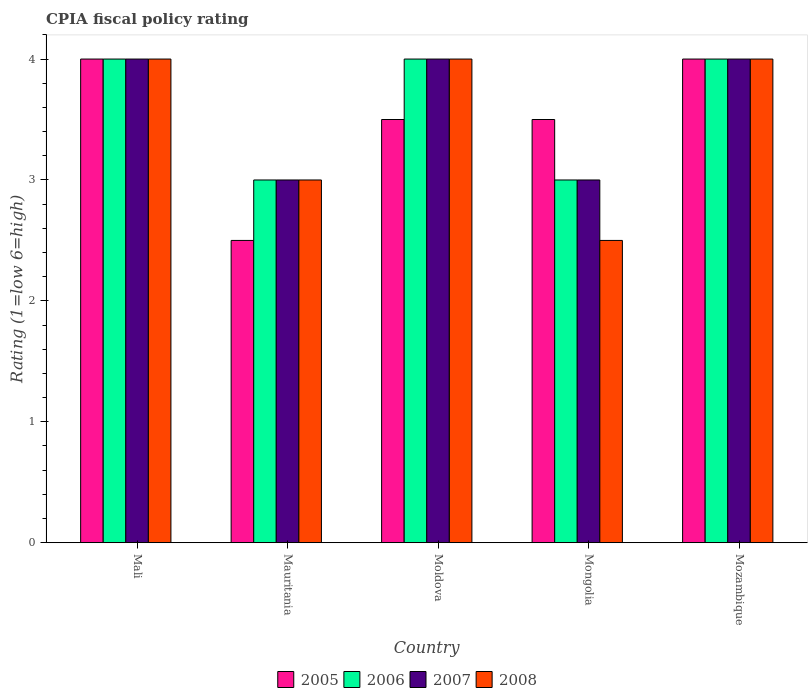Are the number of bars per tick equal to the number of legend labels?
Offer a terse response. Yes. How many bars are there on the 3rd tick from the left?
Give a very brief answer. 4. How many bars are there on the 3rd tick from the right?
Provide a short and direct response. 4. What is the label of the 5th group of bars from the left?
Offer a terse response. Mozambique. In how many cases, is the number of bars for a given country not equal to the number of legend labels?
Your answer should be compact. 0. Across all countries, what is the minimum CPIA rating in 2008?
Offer a terse response. 2.5. In which country was the CPIA rating in 2006 maximum?
Your answer should be very brief. Mali. In which country was the CPIA rating in 2007 minimum?
Provide a short and direct response. Mauritania. What is the average CPIA rating in 2005 per country?
Your answer should be very brief. 3.5. What is the difference between the CPIA rating of/in 2006 and CPIA rating of/in 2008 in Mongolia?
Offer a very short reply. 0.5. In how many countries, is the CPIA rating in 2008 greater than 2.2?
Your answer should be very brief. 5. What is the ratio of the CPIA rating in 2007 in Mauritania to that in Mozambique?
Provide a short and direct response. 0.75. What is the difference between the highest and the second highest CPIA rating in 2005?
Give a very brief answer. -0.5. Is the sum of the CPIA rating in 2008 in Mauritania and Mozambique greater than the maximum CPIA rating in 2006 across all countries?
Ensure brevity in your answer.  Yes. What does the 1st bar from the left in Mauritania represents?
Your answer should be very brief. 2005. Is it the case that in every country, the sum of the CPIA rating in 2008 and CPIA rating in 2005 is greater than the CPIA rating in 2007?
Provide a short and direct response. Yes. Are all the bars in the graph horizontal?
Provide a short and direct response. No. Where does the legend appear in the graph?
Your answer should be very brief. Bottom center. What is the title of the graph?
Ensure brevity in your answer.  CPIA fiscal policy rating. Does "1985" appear as one of the legend labels in the graph?
Make the answer very short. No. What is the label or title of the Y-axis?
Offer a terse response. Rating (1=low 6=high). What is the Rating (1=low 6=high) in 2005 in Mali?
Provide a short and direct response. 4. What is the Rating (1=low 6=high) of 2007 in Mauritania?
Your answer should be compact. 3. What is the Rating (1=low 6=high) of 2006 in Moldova?
Provide a short and direct response. 4. What is the Rating (1=low 6=high) in 2007 in Moldova?
Provide a succinct answer. 4. What is the Rating (1=low 6=high) in 2008 in Moldova?
Give a very brief answer. 4. What is the Rating (1=low 6=high) in 2005 in Mozambique?
Offer a very short reply. 4. What is the Rating (1=low 6=high) in 2008 in Mozambique?
Offer a very short reply. 4. Across all countries, what is the maximum Rating (1=low 6=high) in 2005?
Your answer should be compact. 4. Across all countries, what is the maximum Rating (1=low 6=high) of 2006?
Provide a succinct answer. 4. Across all countries, what is the maximum Rating (1=low 6=high) in 2007?
Keep it short and to the point. 4. Across all countries, what is the maximum Rating (1=low 6=high) in 2008?
Your answer should be compact. 4. Across all countries, what is the minimum Rating (1=low 6=high) of 2006?
Offer a very short reply. 3. Across all countries, what is the minimum Rating (1=low 6=high) of 2007?
Provide a succinct answer. 3. Across all countries, what is the minimum Rating (1=low 6=high) of 2008?
Keep it short and to the point. 2.5. What is the total Rating (1=low 6=high) in 2007 in the graph?
Offer a terse response. 18. What is the difference between the Rating (1=low 6=high) in 2005 in Mali and that in Mauritania?
Keep it short and to the point. 1.5. What is the difference between the Rating (1=low 6=high) in 2006 in Mali and that in Mauritania?
Provide a short and direct response. 1. What is the difference between the Rating (1=low 6=high) of 2008 in Mali and that in Mauritania?
Give a very brief answer. 1. What is the difference between the Rating (1=low 6=high) in 2005 in Mali and that in Moldova?
Your answer should be compact. 0.5. What is the difference between the Rating (1=low 6=high) in 2006 in Mali and that in Mongolia?
Your answer should be very brief. 1. What is the difference between the Rating (1=low 6=high) of 2007 in Mali and that in Mongolia?
Give a very brief answer. 1. What is the difference between the Rating (1=low 6=high) of 2008 in Mali and that in Mongolia?
Keep it short and to the point. 1.5. What is the difference between the Rating (1=low 6=high) in 2005 in Mali and that in Mozambique?
Ensure brevity in your answer.  0. What is the difference between the Rating (1=low 6=high) in 2006 in Mali and that in Mozambique?
Give a very brief answer. 0. What is the difference between the Rating (1=low 6=high) in 2007 in Mali and that in Mozambique?
Offer a terse response. 0. What is the difference between the Rating (1=low 6=high) of 2008 in Mali and that in Mozambique?
Your answer should be very brief. 0. What is the difference between the Rating (1=low 6=high) of 2005 in Mauritania and that in Moldova?
Ensure brevity in your answer.  -1. What is the difference between the Rating (1=low 6=high) of 2007 in Mauritania and that in Moldova?
Your answer should be compact. -1. What is the difference between the Rating (1=low 6=high) of 2008 in Mauritania and that in Moldova?
Offer a very short reply. -1. What is the difference between the Rating (1=low 6=high) in 2005 in Mauritania and that in Mongolia?
Provide a short and direct response. -1. What is the difference between the Rating (1=low 6=high) in 2006 in Mauritania and that in Mozambique?
Your answer should be compact. -1. What is the difference between the Rating (1=low 6=high) in 2008 in Mauritania and that in Mozambique?
Provide a succinct answer. -1. What is the difference between the Rating (1=low 6=high) of 2005 in Moldova and that in Mongolia?
Keep it short and to the point. 0. What is the difference between the Rating (1=low 6=high) in 2006 in Moldova and that in Mongolia?
Make the answer very short. 1. What is the difference between the Rating (1=low 6=high) of 2007 in Moldova and that in Mongolia?
Your answer should be compact. 1. What is the difference between the Rating (1=low 6=high) in 2008 in Moldova and that in Mongolia?
Make the answer very short. 1.5. What is the difference between the Rating (1=low 6=high) in 2005 in Moldova and that in Mozambique?
Offer a terse response. -0.5. What is the difference between the Rating (1=low 6=high) of 2006 in Moldova and that in Mozambique?
Make the answer very short. 0. What is the difference between the Rating (1=low 6=high) in 2008 in Moldova and that in Mozambique?
Offer a very short reply. 0. What is the difference between the Rating (1=low 6=high) in 2005 in Mongolia and that in Mozambique?
Make the answer very short. -0.5. What is the difference between the Rating (1=low 6=high) of 2006 in Mongolia and that in Mozambique?
Keep it short and to the point. -1. What is the difference between the Rating (1=low 6=high) in 2005 in Mali and the Rating (1=low 6=high) in 2007 in Mauritania?
Offer a terse response. 1. What is the difference between the Rating (1=low 6=high) in 2006 in Mali and the Rating (1=low 6=high) in 2007 in Mauritania?
Give a very brief answer. 1. What is the difference between the Rating (1=low 6=high) in 2005 in Mali and the Rating (1=low 6=high) in 2006 in Moldova?
Offer a very short reply. 0. What is the difference between the Rating (1=low 6=high) in 2005 in Mali and the Rating (1=low 6=high) in 2007 in Moldova?
Offer a terse response. 0. What is the difference between the Rating (1=low 6=high) of 2006 in Mali and the Rating (1=low 6=high) of 2008 in Moldova?
Provide a short and direct response. 0. What is the difference between the Rating (1=low 6=high) of 2007 in Mali and the Rating (1=low 6=high) of 2008 in Moldova?
Give a very brief answer. 0. What is the difference between the Rating (1=low 6=high) in 2005 in Mali and the Rating (1=low 6=high) in 2007 in Mongolia?
Provide a succinct answer. 1. What is the difference between the Rating (1=low 6=high) in 2007 in Mali and the Rating (1=low 6=high) in 2008 in Mongolia?
Make the answer very short. 1.5. What is the difference between the Rating (1=low 6=high) of 2005 in Mali and the Rating (1=low 6=high) of 2006 in Mozambique?
Provide a succinct answer. 0. What is the difference between the Rating (1=low 6=high) of 2005 in Mali and the Rating (1=low 6=high) of 2007 in Mozambique?
Your answer should be compact. 0. What is the difference between the Rating (1=low 6=high) of 2005 in Mali and the Rating (1=low 6=high) of 2008 in Mozambique?
Give a very brief answer. 0. What is the difference between the Rating (1=low 6=high) in 2007 in Mali and the Rating (1=low 6=high) in 2008 in Mozambique?
Provide a short and direct response. 0. What is the difference between the Rating (1=low 6=high) of 2005 in Mauritania and the Rating (1=low 6=high) of 2006 in Moldova?
Provide a succinct answer. -1.5. What is the difference between the Rating (1=low 6=high) of 2005 in Mauritania and the Rating (1=low 6=high) of 2007 in Moldova?
Provide a short and direct response. -1.5. What is the difference between the Rating (1=low 6=high) of 2006 in Mauritania and the Rating (1=low 6=high) of 2007 in Moldova?
Your response must be concise. -1. What is the difference between the Rating (1=low 6=high) in 2006 in Mauritania and the Rating (1=low 6=high) in 2008 in Moldova?
Keep it short and to the point. -1. What is the difference between the Rating (1=low 6=high) in 2005 in Mauritania and the Rating (1=low 6=high) in 2006 in Mongolia?
Your response must be concise. -0.5. What is the difference between the Rating (1=low 6=high) in 2006 in Mauritania and the Rating (1=low 6=high) in 2007 in Mongolia?
Keep it short and to the point. 0. What is the difference between the Rating (1=low 6=high) in 2006 in Mauritania and the Rating (1=low 6=high) in 2008 in Mongolia?
Offer a very short reply. 0.5. What is the difference between the Rating (1=low 6=high) of 2006 in Mauritania and the Rating (1=low 6=high) of 2008 in Mozambique?
Give a very brief answer. -1. What is the difference between the Rating (1=low 6=high) in 2005 in Moldova and the Rating (1=low 6=high) in 2008 in Mongolia?
Provide a short and direct response. 1. What is the difference between the Rating (1=low 6=high) in 2005 in Moldova and the Rating (1=low 6=high) in 2006 in Mozambique?
Provide a succinct answer. -0.5. What is the difference between the Rating (1=low 6=high) of 2005 in Moldova and the Rating (1=low 6=high) of 2007 in Mozambique?
Your answer should be very brief. -0.5. What is the difference between the Rating (1=low 6=high) in 2006 in Moldova and the Rating (1=low 6=high) in 2007 in Mozambique?
Keep it short and to the point. 0. What is the difference between the Rating (1=low 6=high) of 2006 in Moldova and the Rating (1=low 6=high) of 2008 in Mozambique?
Ensure brevity in your answer.  0. What is the difference between the Rating (1=low 6=high) in 2007 in Moldova and the Rating (1=low 6=high) in 2008 in Mozambique?
Offer a very short reply. 0. What is the difference between the Rating (1=low 6=high) of 2005 in Mongolia and the Rating (1=low 6=high) of 2007 in Mozambique?
Your answer should be compact. -0.5. What is the difference between the Rating (1=low 6=high) of 2006 in Mongolia and the Rating (1=low 6=high) of 2007 in Mozambique?
Keep it short and to the point. -1. What is the difference between the Rating (1=low 6=high) of 2007 in Mongolia and the Rating (1=low 6=high) of 2008 in Mozambique?
Give a very brief answer. -1. What is the difference between the Rating (1=low 6=high) of 2006 and Rating (1=low 6=high) of 2007 in Mali?
Offer a very short reply. 0. What is the difference between the Rating (1=low 6=high) in 2006 and Rating (1=low 6=high) in 2008 in Mali?
Your response must be concise. 0. What is the difference between the Rating (1=low 6=high) of 2005 and Rating (1=low 6=high) of 2006 in Mauritania?
Give a very brief answer. -0.5. What is the difference between the Rating (1=low 6=high) of 2005 and Rating (1=low 6=high) of 2008 in Mauritania?
Provide a succinct answer. -0.5. What is the difference between the Rating (1=low 6=high) of 2006 and Rating (1=low 6=high) of 2007 in Mauritania?
Offer a terse response. 0. What is the difference between the Rating (1=low 6=high) in 2006 and Rating (1=low 6=high) in 2008 in Mauritania?
Your answer should be compact. 0. What is the difference between the Rating (1=low 6=high) in 2007 and Rating (1=low 6=high) in 2008 in Mauritania?
Provide a short and direct response. 0. What is the difference between the Rating (1=low 6=high) in 2005 and Rating (1=low 6=high) in 2006 in Mongolia?
Provide a short and direct response. 0.5. What is the difference between the Rating (1=low 6=high) of 2005 and Rating (1=low 6=high) of 2008 in Mongolia?
Your answer should be compact. 1. What is the difference between the Rating (1=low 6=high) of 2006 and Rating (1=low 6=high) of 2008 in Mongolia?
Your answer should be compact. 0.5. What is the difference between the Rating (1=low 6=high) of 2005 and Rating (1=low 6=high) of 2008 in Mozambique?
Provide a short and direct response. 0. What is the difference between the Rating (1=low 6=high) in 2006 and Rating (1=low 6=high) in 2007 in Mozambique?
Keep it short and to the point. 0. What is the difference between the Rating (1=low 6=high) in 2006 and Rating (1=low 6=high) in 2008 in Mozambique?
Ensure brevity in your answer.  0. What is the ratio of the Rating (1=low 6=high) in 2005 in Mali to that in Mauritania?
Give a very brief answer. 1.6. What is the ratio of the Rating (1=low 6=high) of 2007 in Mali to that in Mauritania?
Give a very brief answer. 1.33. What is the ratio of the Rating (1=low 6=high) of 2007 in Mali to that in Moldova?
Offer a very short reply. 1. What is the ratio of the Rating (1=low 6=high) in 2005 in Mali to that in Mongolia?
Keep it short and to the point. 1.14. What is the ratio of the Rating (1=low 6=high) in 2007 in Mali to that in Mongolia?
Keep it short and to the point. 1.33. What is the ratio of the Rating (1=low 6=high) in 2008 in Mali to that in Mongolia?
Provide a succinct answer. 1.6. What is the ratio of the Rating (1=low 6=high) of 2005 in Mali to that in Mozambique?
Your response must be concise. 1. What is the ratio of the Rating (1=low 6=high) of 2008 in Mali to that in Mozambique?
Your answer should be very brief. 1. What is the ratio of the Rating (1=low 6=high) in 2005 in Mauritania to that in Mongolia?
Your answer should be compact. 0.71. What is the ratio of the Rating (1=low 6=high) of 2006 in Mauritania to that in Mongolia?
Give a very brief answer. 1. What is the ratio of the Rating (1=low 6=high) in 2007 in Mauritania to that in Mongolia?
Your response must be concise. 1. What is the ratio of the Rating (1=low 6=high) of 2007 in Mauritania to that in Mozambique?
Your answer should be compact. 0.75. What is the ratio of the Rating (1=low 6=high) in 2008 in Mauritania to that in Mozambique?
Keep it short and to the point. 0.75. What is the ratio of the Rating (1=low 6=high) in 2005 in Moldova to that in Mongolia?
Your response must be concise. 1. What is the ratio of the Rating (1=low 6=high) of 2006 in Moldova to that in Mongolia?
Your response must be concise. 1.33. What is the ratio of the Rating (1=low 6=high) in 2007 in Moldova to that in Mongolia?
Provide a succinct answer. 1.33. What is the ratio of the Rating (1=low 6=high) of 2007 in Moldova to that in Mozambique?
Your response must be concise. 1. What is the ratio of the Rating (1=low 6=high) of 2005 in Mongolia to that in Mozambique?
Make the answer very short. 0.88. What is the ratio of the Rating (1=low 6=high) in 2006 in Mongolia to that in Mozambique?
Your answer should be very brief. 0.75. What is the difference between the highest and the lowest Rating (1=low 6=high) of 2005?
Provide a succinct answer. 1.5. What is the difference between the highest and the lowest Rating (1=low 6=high) of 2006?
Your answer should be very brief. 1. 